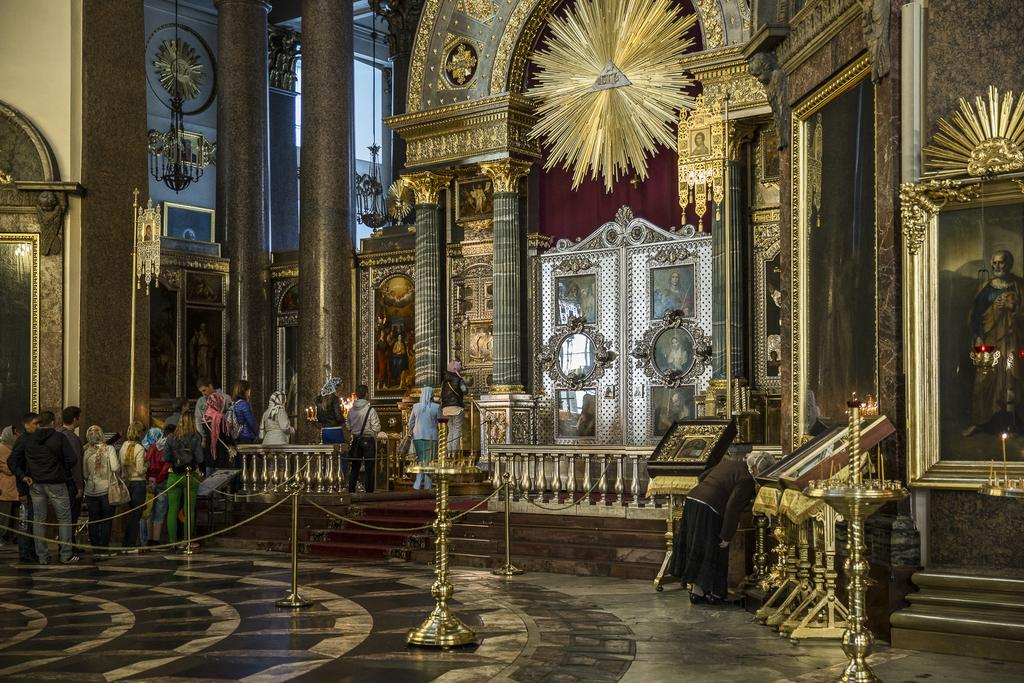Where is the image taken? The image is inside a church. What are the people in the image doing? The people are standing in a queue. What can be seen in the image besides the people? There are stands, pillars, photo frames on the wall, and glass windows in the background. What type of distribution is being used for the brass in the image? There is no mention of brass or any distribution in the image. --- Facts: 1. There is a person in the image. 2. The person is wearing a hat. 3. The person is holding a book. 4. The background is a library. 5. There are bookshelves in the background. Absurd Topics: elephant, piano, dance Conversation: Who or what is in the image? There is a person in the image. What is the person wearing? The person is wearing a hat. What is the person holding? The person is holding a book. What is the background of the image? The background is a library. What can be seen in the background? There are bookshelves in the background. Reasoning: Let's think step by step in order to produce the conversation. We start by identifying the main subject of the image, which is the person. Next, we describe the person's attire, noting that they are wearing a hat. Then, we observe the actions of the person, noting that they are holding a book. Finally, we describe the setting of the image, which is a library. We ensure that each question can be answered definitively with the information given. Absurd Question/Answer: How many elephants can be seen playing the piano in the image? There are no elephants visible in the image. --- Facts: 1. There is a dog in the image. 2. The dog is sitting on a chair. 3. The dog is wearing a bow tie. 4. The background is a park. 5. There are trees in the background. Absurd Topics: unicorn, rainbow, parade Conversation: What type of animal is in the image? There is a dog in the image. What is the dog doing in the image? The dog is sitting on a chair. What is the dog wearing in the image? The dog is wearing a bow tie. What is the background of the image? The background is a park. What can be seen in the background? There are trees in the background. Reasoning: Let's think step by step in order to produce the conversation. We start by identifying the main subject of the image, which is the dog. Next, we describe the actions of the dog, noting that they are sitting on a chair. Then, we observe the attire of 